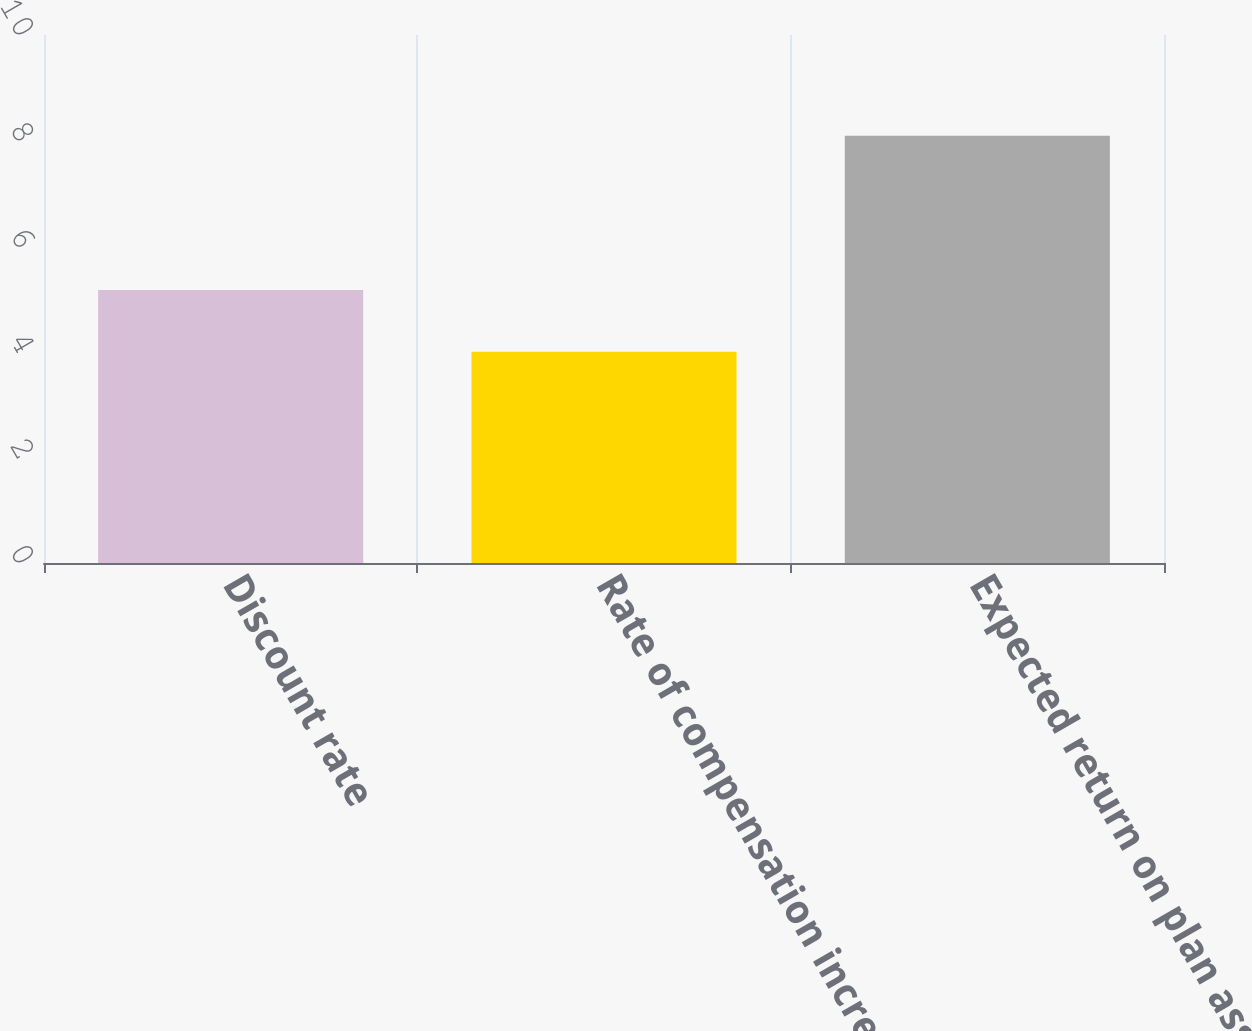<chart> <loc_0><loc_0><loc_500><loc_500><bar_chart><fcel>Discount rate<fcel>Rate of compensation increase<fcel>Expected return on plan assets<nl><fcel>5.17<fcel>4<fcel>8.09<nl></chart> 